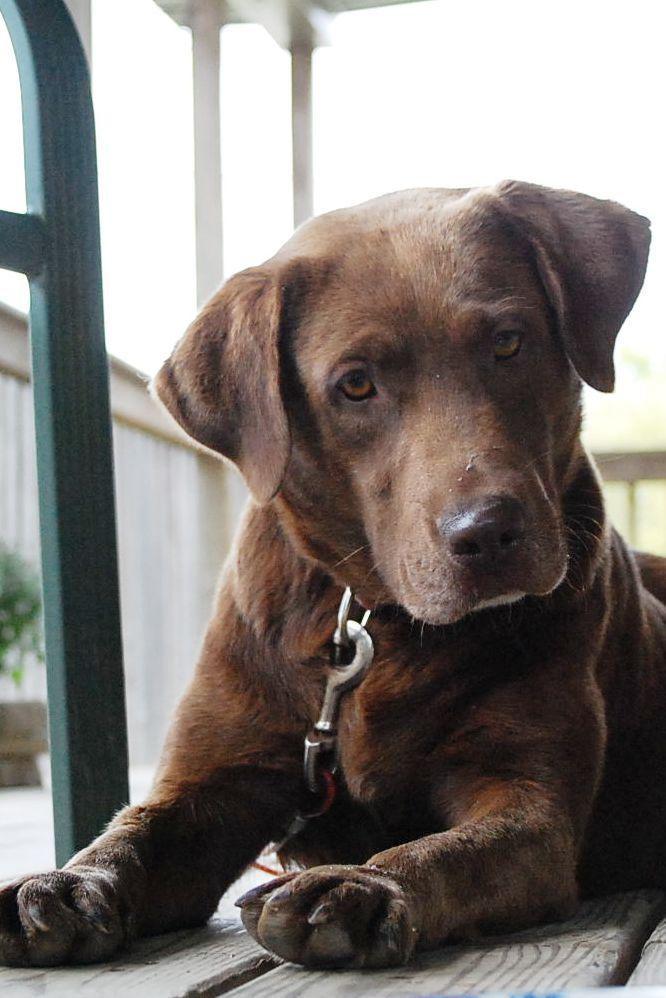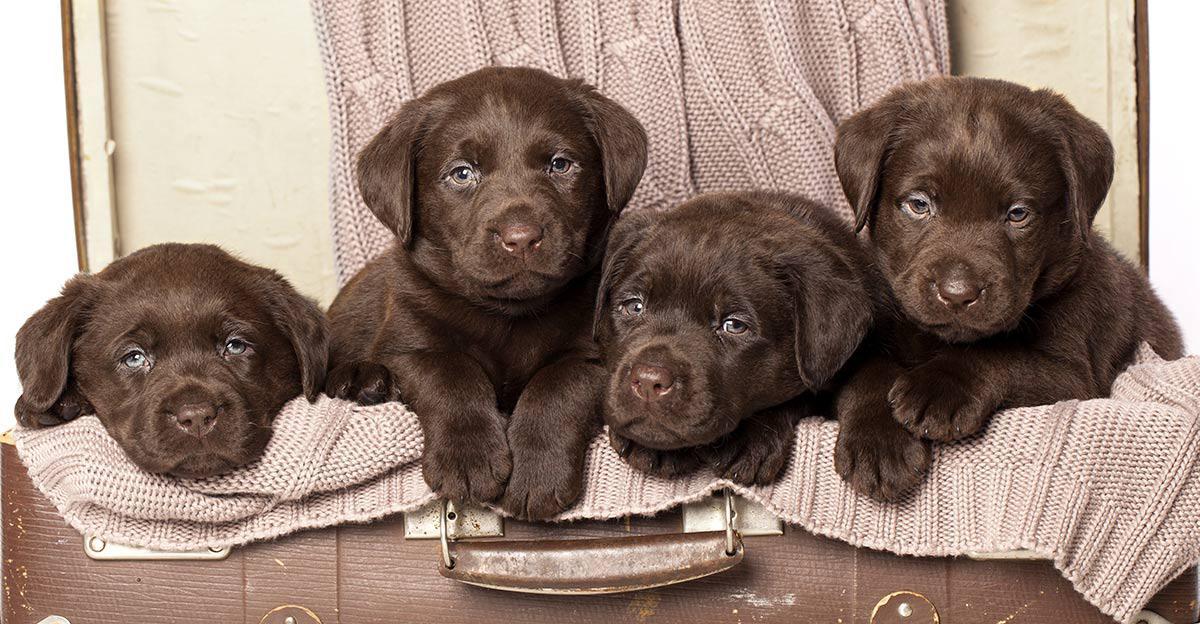The first image is the image on the left, the second image is the image on the right. Examine the images to the left and right. Is the description "There are no fewer than three dogs in one of the images." accurate? Answer yes or no. Yes. The first image is the image on the left, the second image is the image on the right. Assess this claim about the two images: "One image features at least three dogs posed in a row.". Correct or not? Answer yes or no. Yes. 